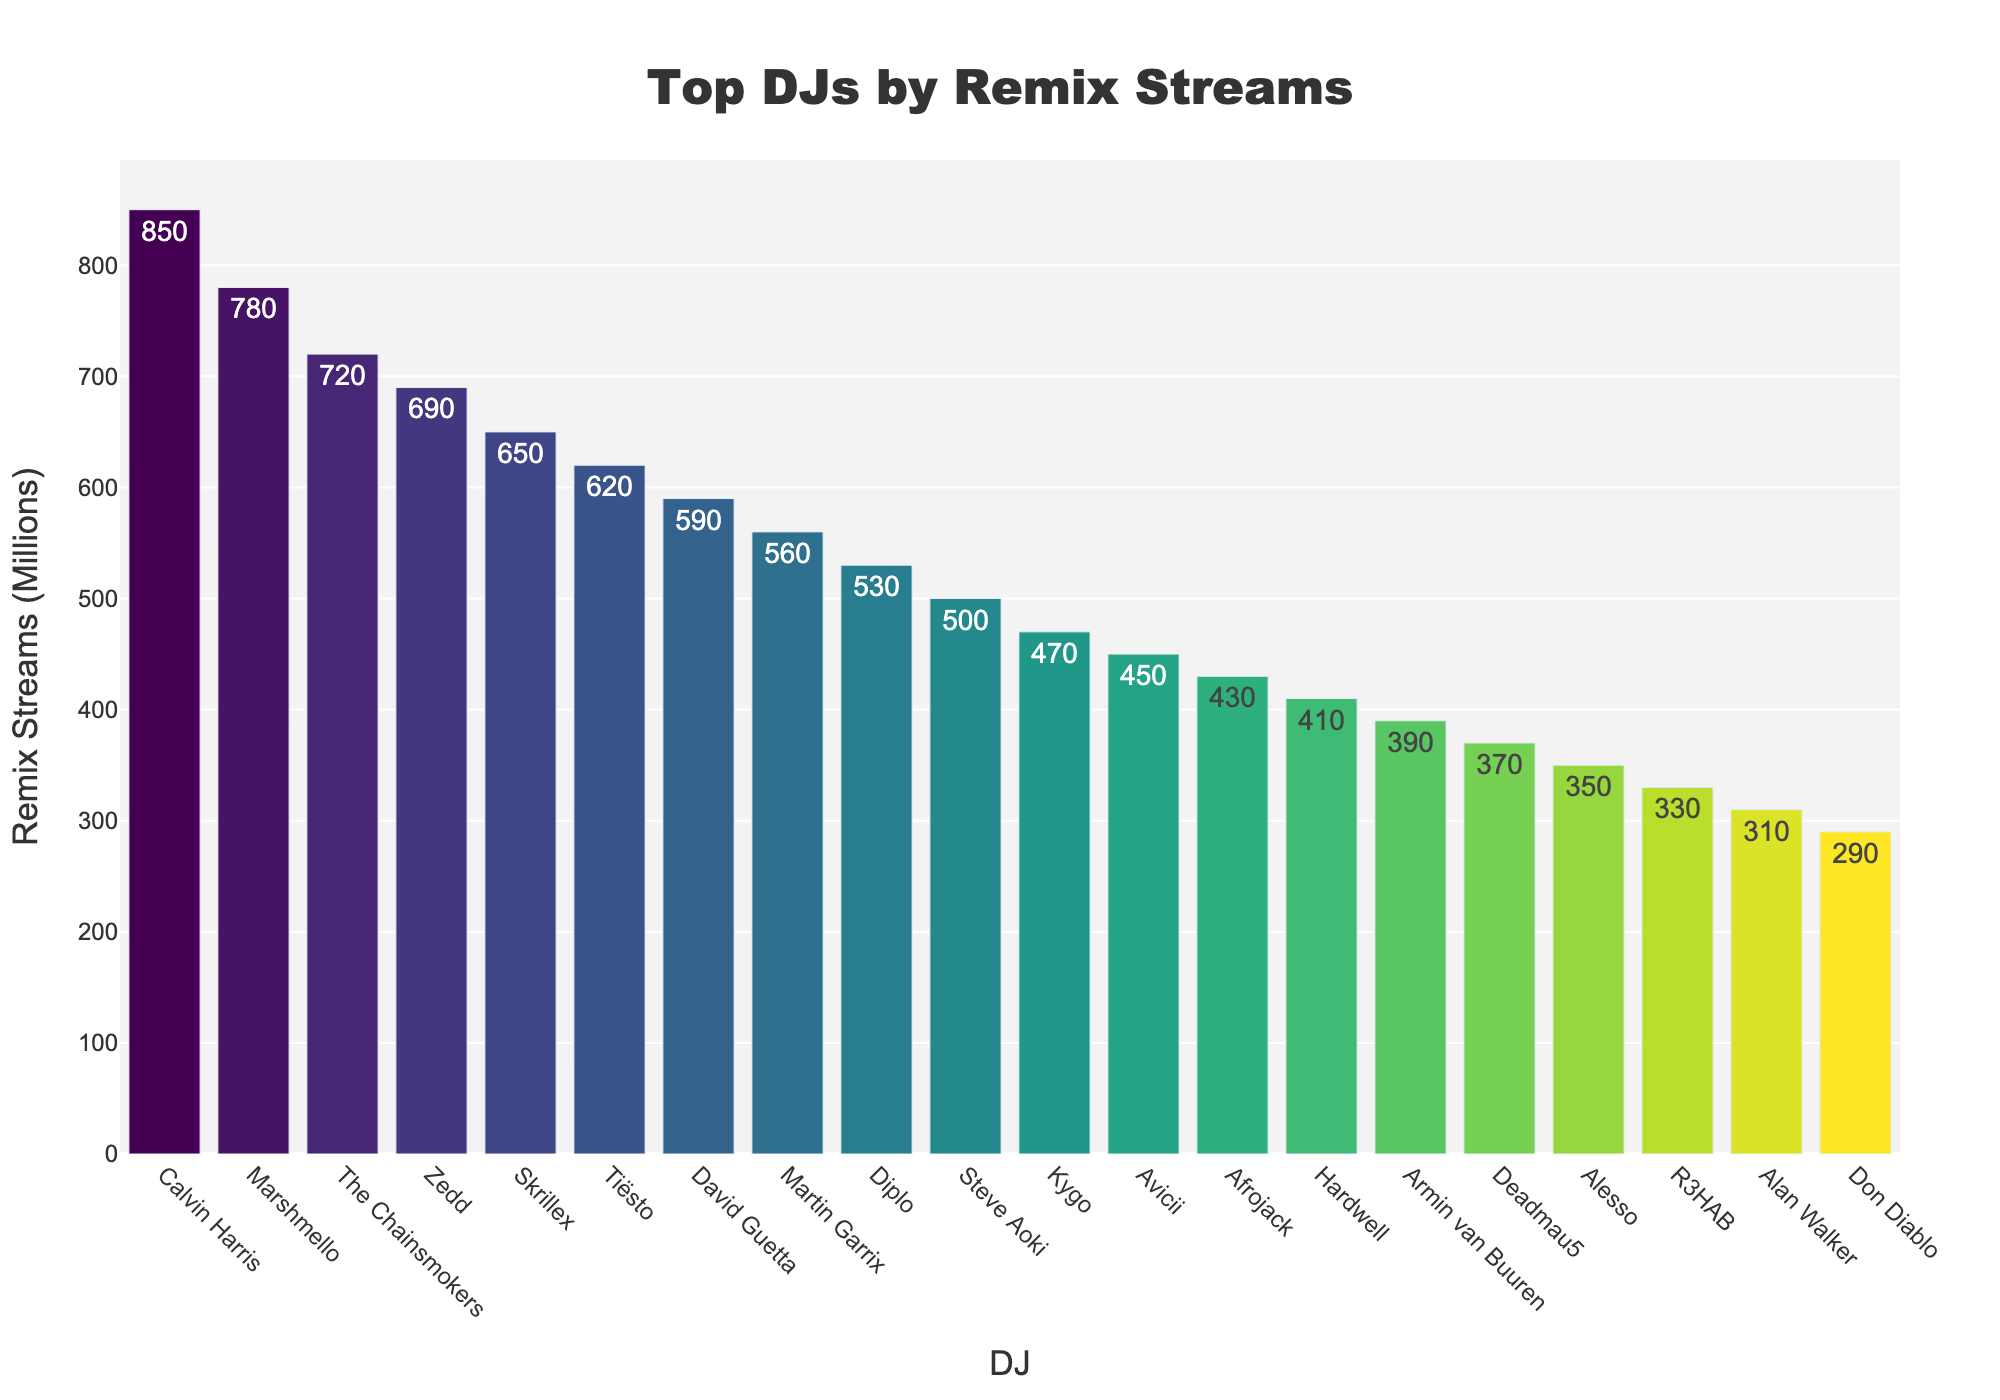Which DJ has the highest number of remix streams? The bar with the tallest height represents the DJ with the most streams. The figure shows Calvin Harris at the top with 850 million streams.
Answer: Calvin Harris Which DJ has the lowest number of remix streams in the figure? The bar with the shortest height indicates the DJ with the fewest streams. The figure shows Don Diablo with 290 million streams.
Answer: Don Diablo What is the total number of remix streams for the top 3 DJs? The top 3 DJs are Calvin Harris (850M), Marshmello (780M), and The Chainsmokers (720M). Summing these, we get 850 + 780 + 720 = 2350 million streams.
Answer: 2350 million Who has more streams: David Guetta or Martin Garrix? Comparing the heights, David Guetta has 590 million streams while Martin Garrix has 560 million streams.
Answer: David Guetta What is the average number of remix streams for the DJs listed? Sum all the streams for the listed DJs and divide by the number of DJs. The total is 17010 million (sum of all values). There are 20 DJs. So, the average is 17010 / 20 = 850.5 million.
Answer: 850.5 million What is the difference in remix streams between Tiësto and Kygo? Tiësto has 620 million streams while Kygo has 470 million streams. So, the difference is 620 - 470 = 150 million.
Answer: 150 million Which DJ has slightly fewer remix streams than Skrillex? Observing the height of bars near Skrillex, Tiësto has 620 million streams, slightly fewer than Skrillex's 650 million streams.
Answer: Tiësto Are there more DJs with remix streams above or below Zedd's count? Zedd has 690 million streams. Counting the DJs above and below, there are 3 DJs with more streams and 16 with fewer streams.
Answer: More below Which two DJs have the closest number of remix streams? Comparing the gaps visually, Zedd (690M) and Skrillex (650M) have the closest number of streams with a difference of 40 million.
Answer: Zedd and Skrillex How many DJs have more than 600 million remix streams? Counting the bars higher than the value corresponding to 600 million, there are 5 DJs (Calvin Harris, Marshmello, The Chainsmokers, Zedd, Skrillex, and Tiësto).
Answer: 6 